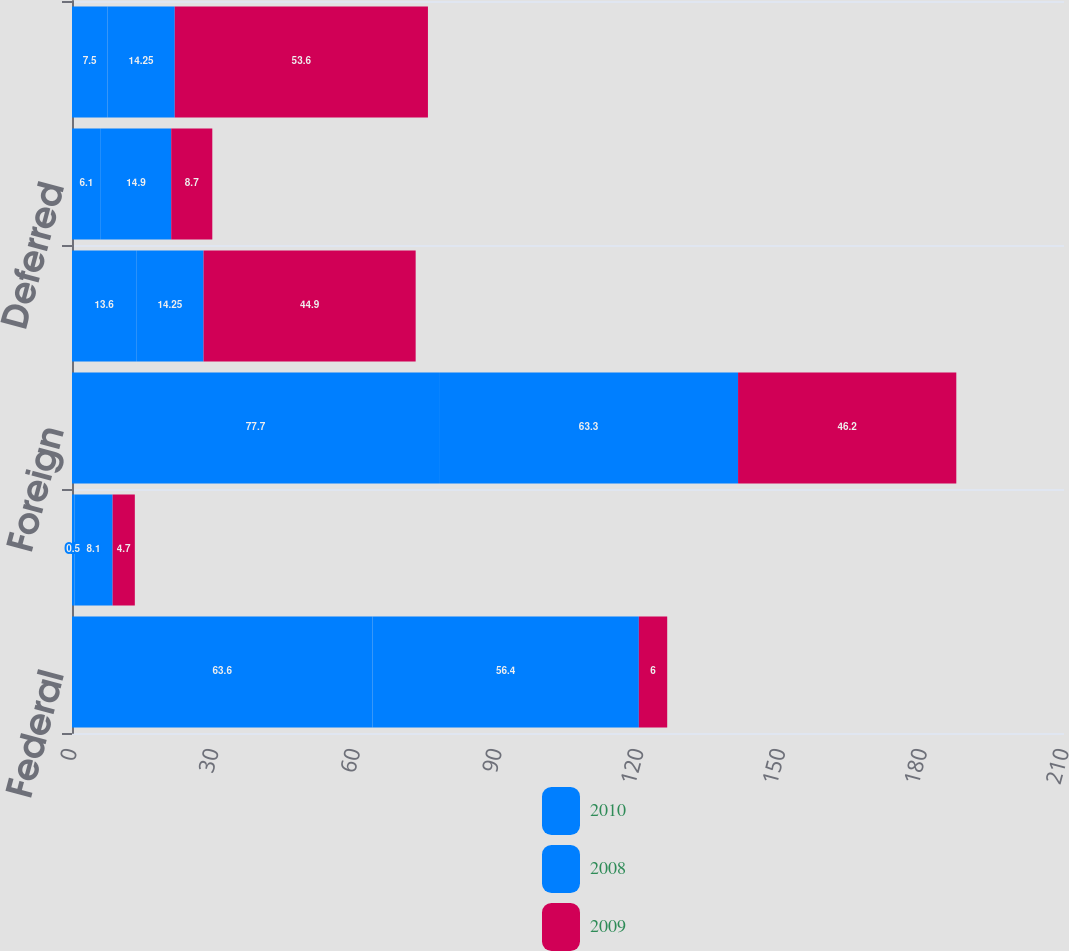Convert chart to OTSL. <chart><loc_0><loc_0><loc_500><loc_500><stacked_bar_chart><ecel><fcel>Federal<fcel>State<fcel>Foreign<fcel>Total current<fcel>Deferred<fcel>Total provision<nl><fcel>2010<fcel>63.6<fcel>0.5<fcel>77.7<fcel>13.6<fcel>6.1<fcel>7.5<nl><fcel>2008<fcel>56.4<fcel>8.1<fcel>63.3<fcel>14.25<fcel>14.9<fcel>14.25<nl><fcel>2009<fcel>6<fcel>4.7<fcel>46.2<fcel>44.9<fcel>8.7<fcel>53.6<nl></chart> 